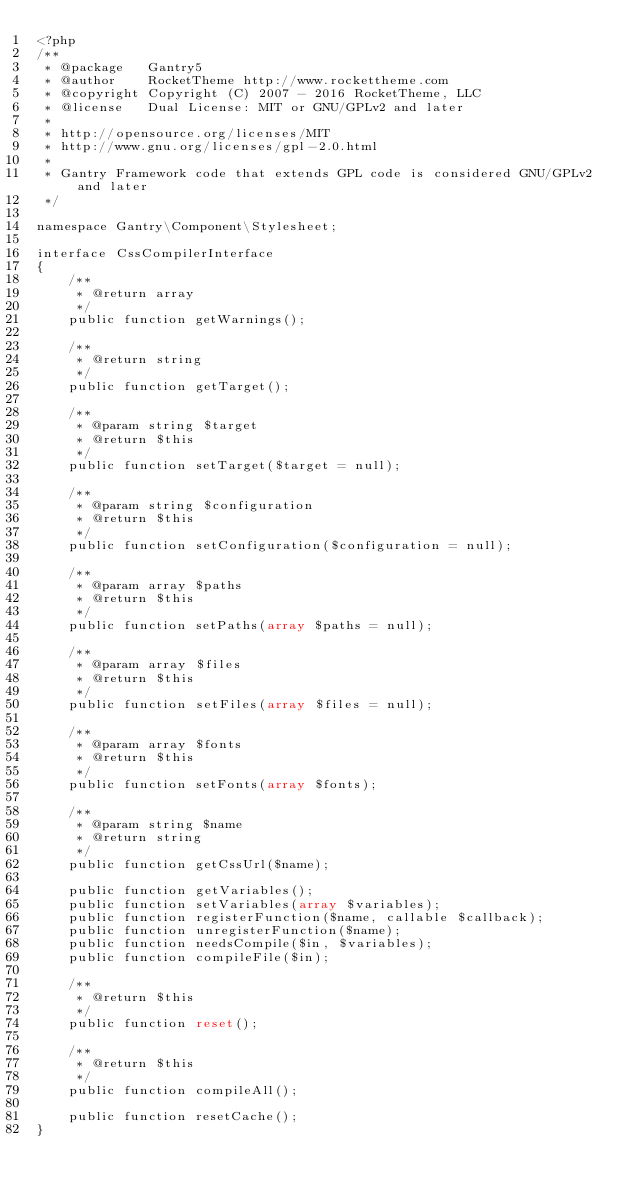<code> <loc_0><loc_0><loc_500><loc_500><_PHP_><?php
/**
 * @package   Gantry5
 * @author    RocketTheme http://www.rockettheme.com
 * @copyright Copyright (C) 2007 - 2016 RocketTheme, LLC
 * @license   Dual License: MIT or GNU/GPLv2 and later
 *
 * http://opensource.org/licenses/MIT
 * http://www.gnu.org/licenses/gpl-2.0.html
 *
 * Gantry Framework code that extends GPL code is considered GNU/GPLv2 and later
 */

namespace Gantry\Component\Stylesheet;

interface CssCompilerInterface
{
    /**
     * @return array
     */
    public function getWarnings();

    /**
     * @return string
     */
    public function getTarget();

    /**
     * @param string $target
     * @return $this
     */
    public function setTarget($target = null);

    /**
     * @param string $configuration
     * @return $this
     */
    public function setConfiguration($configuration = null);

    /**
     * @param array $paths
     * @return $this
     */
    public function setPaths(array $paths = null);

    /**
     * @param array $files
     * @return $this
     */
    public function setFiles(array $files = null);

    /**
     * @param array $fonts
     * @return $this
     */
    public function setFonts(array $fonts);

    /**
     * @param string $name
     * @return string
     */
    public function getCssUrl($name);

    public function getVariables();
    public function setVariables(array $variables);
    public function registerFunction($name, callable $callback);
    public function unregisterFunction($name);
    public function needsCompile($in, $variables);
    public function compileFile($in);

    /**
     * @return $this
     */
    public function reset();

    /**
     * @return $this
     */
    public function compileAll();

    public function resetCache();
}
</code> 